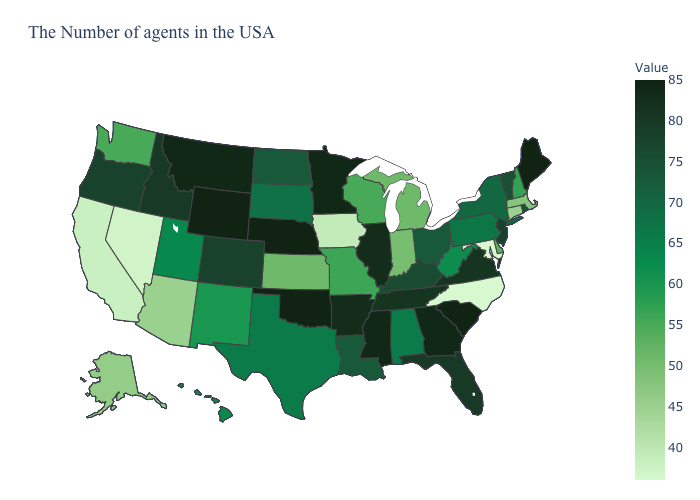Does South Carolina have a higher value than Iowa?
Give a very brief answer. Yes. Does the map have missing data?
Keep it brief. No. Does the map have missing data?
Give a very brief answer. No. Does Hawaii have a lower value than North Dakota?
Write a very short answer. Yes. Does Maryland have the lowest value in the USA?
Answer briefly. Yes. Does North Carolina have the lowest value in the USA?
Short answer required. Yes. Does North Carolina have the lowest value in the USA?
Keep it brief. Yes. Does Montana have the highest value in the USA?
Answer briefly. No. 